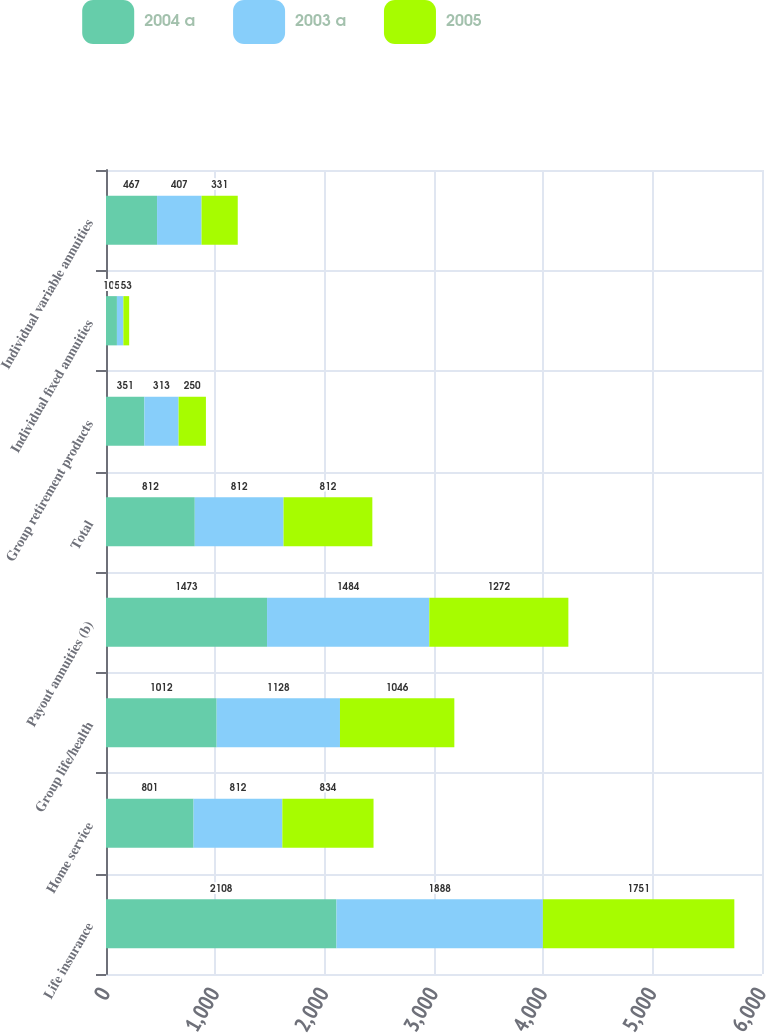Convert chart. <chart><loc_0><loc_0><loc_500><loc_500><stacked_bar_chart><ecel><fcel>Life insurance<fcel>Home service<fcel>Group life/health<fcel>Payout annuities (b)<fcel>Total<fcel>Group retirement products<fcel>Individual fixed annuities<fcel>Individual variable annuities<nl><fcel>2004 a<fcel>2108<fcel>801<fcel>1012<fcel>1473<fcel>812<fcel>351<fcel>100<fcel>467<nl><fcel>2003 a<fcel>1888<fcel>812<fcel>1128<fcel>1484<fcel>812<fcel>313<fcel>59<fcel>407<nl><fcel>2005<fcel>1751<fcel>834<fcel>1046<fcel>1272<fcel>812<fcel>250<fcel>53<fcel>331<nl></chart> 